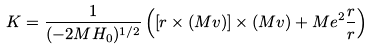Convert formula to latex. <formula><loc_0><loc_0><loc_500><loc_500>K = \frac { 1 } { ( - 2 M H _ { 0 } ) ^ { 1 / 2 } } \left ( [ r \times ( M v ) ] \times ( M v ) + M e ^ { 2 } \frac { r } { r } \right )</formula> 